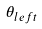<formula> <loc_0><loc_0><loc_500><loc_500>\theta _ { l e f t }</formula> 